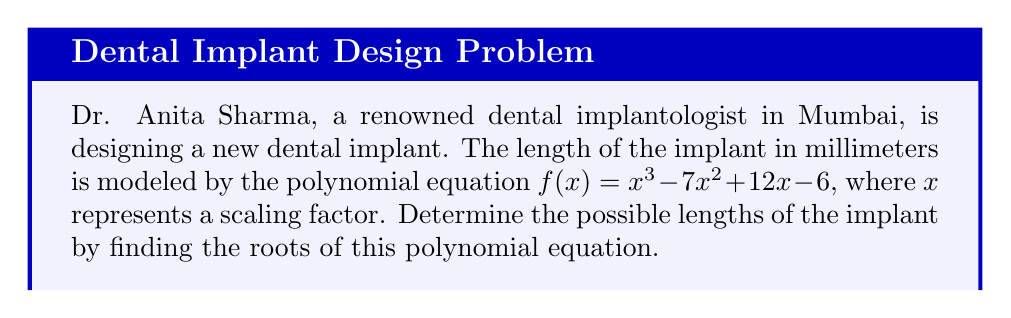What is the answer to this math problem? To find the roots of the polynomial equation $f(x) = x^3 - 7x^2 + 12x - 6$, we need to factor it or use the rational root theorem.

Step 1: Check for rational roots using the rational root theorem.
Possible rational roots: $\pm 1, \pm 2, \pm 3, \pm 6$

Step 2: Use synthetic division to test these potential roots.
Testing $x = 1$:
$$
\begin{array}{r}
1 \enclose{longdiv}{1 \quad -7 \quad 12 \quad -6} \\
\underline{1 \quad -6 \quad 6} \\
1 \quad -6 \quad 6 \quad 0
\end{array}
$$

We find that $x = 1$ is a root.

Step 3: Factor out $(x - 1)$ from the original polynomial.
$f(x) = (x - 1)(x^2 - 6x + 6)$

Step 4: Solve the quadratic equation $x^2 - 6x + 6 = 0$ using the quadratic formula.
$x = \frac{-b \pm \sqrt{b^2 - 4ac}}{2a}$

$x = \frac{6 \pm \sqrt{36 - 24}}{2} = \frac{6 \pm \sqrt{12}}{2} = \frac{6 \pm 2\sqrt{3}}{2}$

$x = 3 \pm \sqrt{3}$

Step 5: Express the roots.
The roots are $x = 1$, $x = 3 + \sqrt{3}$, and $x = 3 - \sqrt{3}$.

Therefore, the possible lengths of the implant are 1 mm, $(3 + \sqrt{3})$ mm, and $(3 - \sqrt{3})$ mm.
Answer: $1$ mm, $(3 + \sqrt{3})$ mm, $(3 - \sqrt{3})$ mm 